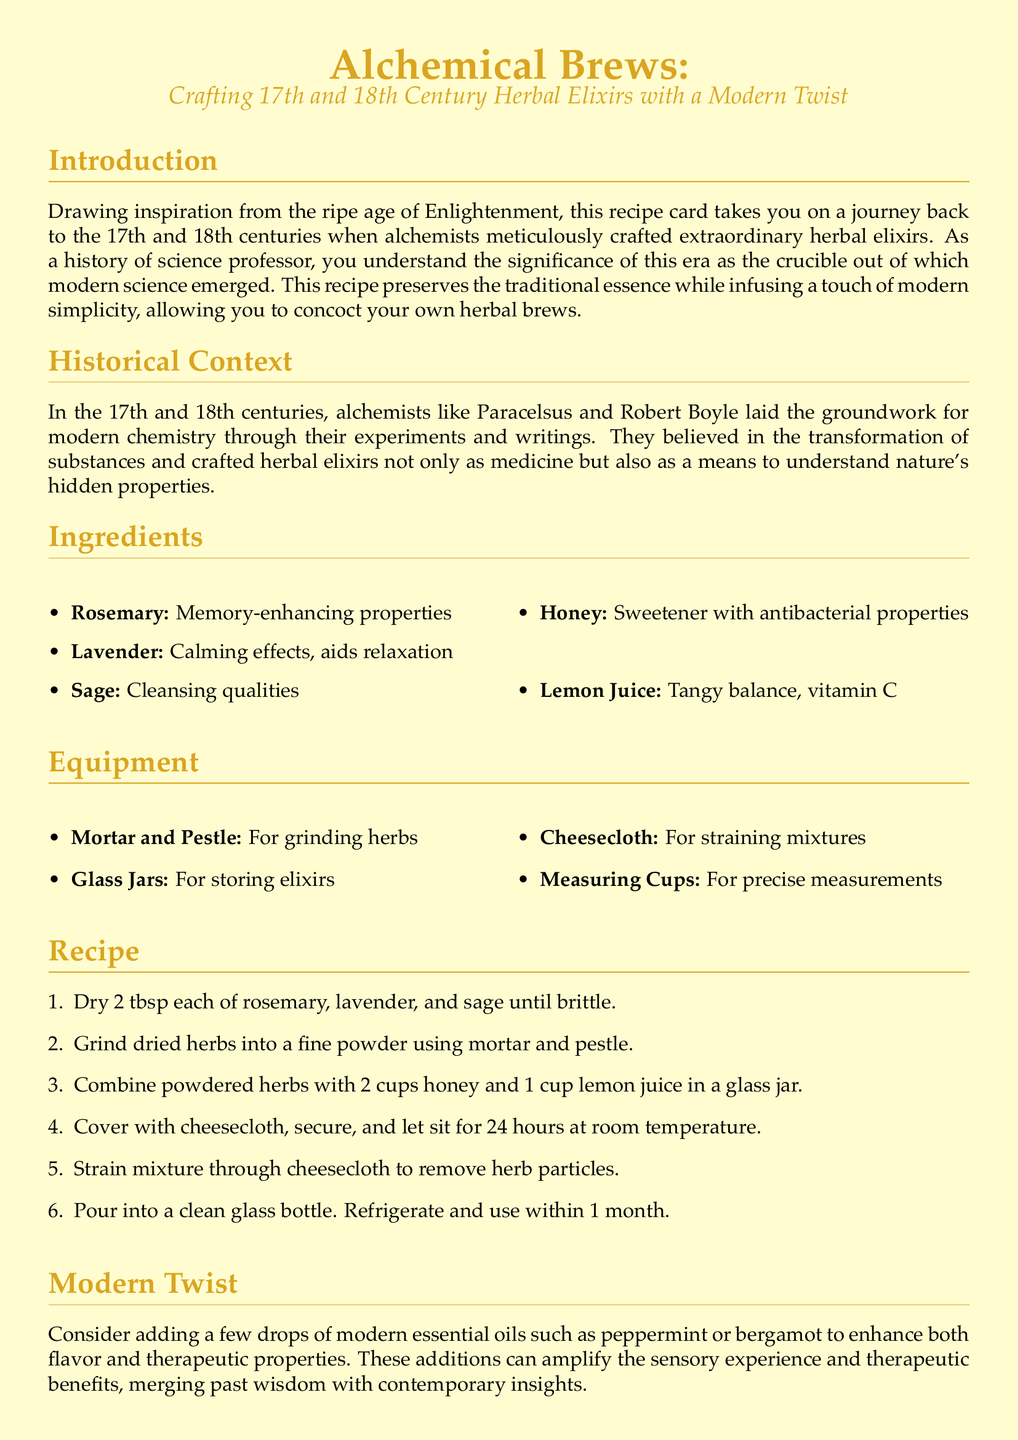what are the primary herbs used in the recipe? The recipe lists rosemary, lavender, and sage as the primary herbs for crafting the elixir.
Answer: rosemary, lavender, sage how much honey is needed? The recipe specifies 2 cups of honey as part of the ingredients.
Answer: 2 cups what is the purpose of using cheesecloth? Cheesecloth is used to strain the mixture to remove herb particles after the elixir has infused.
Answer: straining who are two notable alchemists mentioned? The document mentions Paracelsus and Robert Boyle as notable alchemists who influenced modern chemistry.
Answer: Paracelsus, Robert Boyle how long should the mixture sit before straining? The recipe instructs to let the mixture sit for 24 hours at room temperature.
Answer: 24 hours what modern additions are suggested for enhancing the elixir? The recipe suggests adding a few drops of peppermint or bergamot essential oils for enhanced flavor and therapeutic benefits.
Answer: peppermint, bergamot when should the elixir be used by after making? The elixir should be used within 1 month after preparation.
Answer: 1 month what is the color of the parchment background? The parchment background is colored RGB(255, 253, 208) as described in the document.
Answer: parchment what is the significance of the Enlightenment era to the recipe? The recipe draws inspiration from the Enlightenment era, which is described as significant in the emergence of modern science.
Answer: modern science 